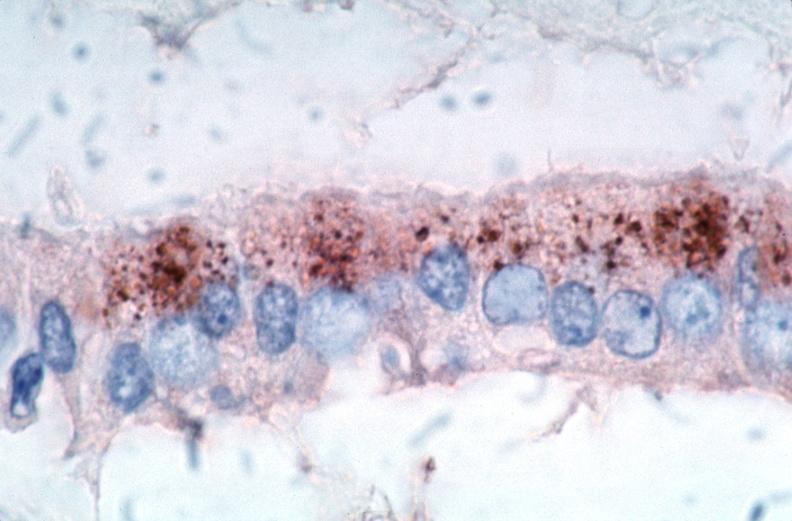does metastatic carcinoma prostate show vasculitis?
Answer the question using a single word or phrase. No 